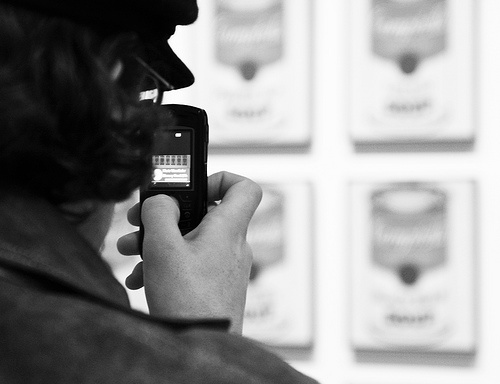Describe the objects in this image and their specific colors. I can see people in black, gray, darkgray, and lightgray tones and cell phone in black, white, darkgray, and gray tones in this image. 